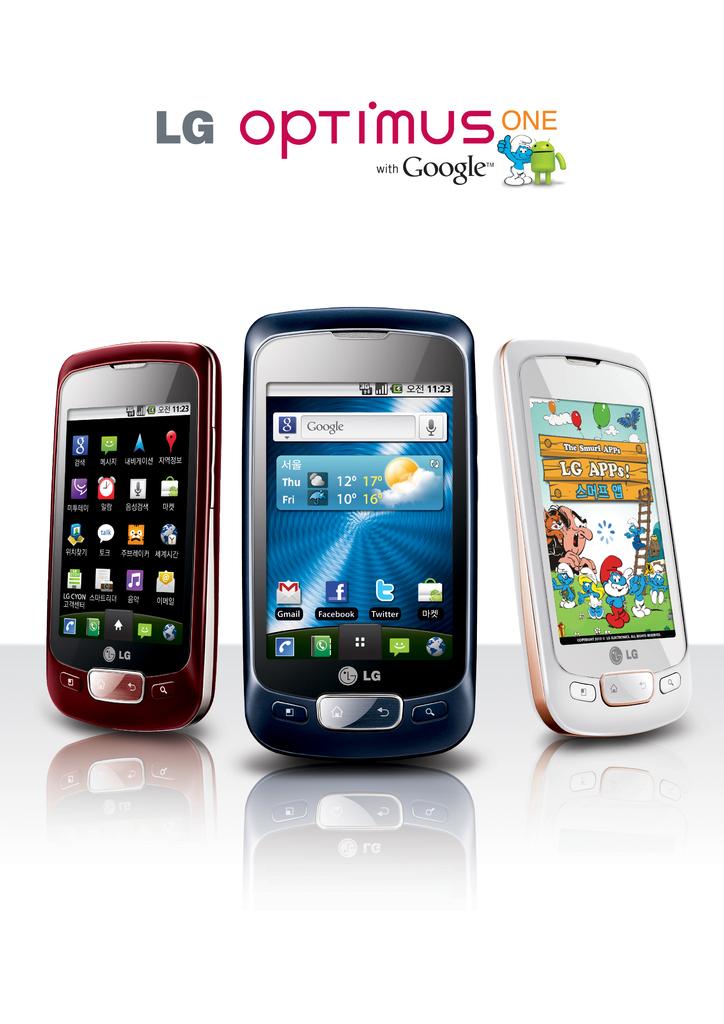What is the search bar?
Give a very brief answer. Google. Which company made these phones?
Offer a very short reply. Lg. 